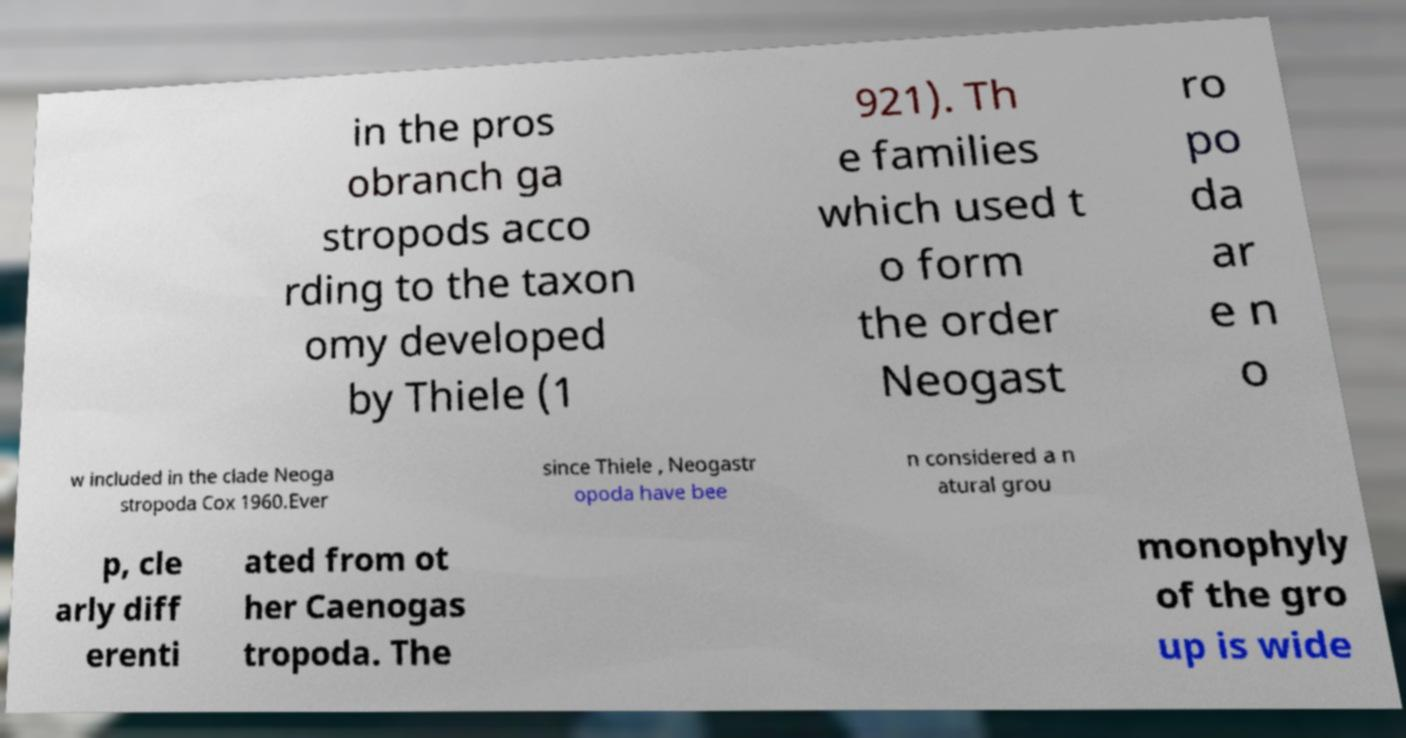Could you assist in decoding the text presented in this image and type it out clearly? in the pros obranch ga stropods acco rding to the taxon omy developed by Thiele (1 921). Th e families which used t o form the order Neogast ro po da ar e n o w included in the clade Neoga stropoda Cox 1960.Ever since Thiele , Neogastr opoda have bee n considered a n atural grou p, cle arly diff erenti ated from ot her Caenogas tropoda. The monophyly of the gro up is wide 